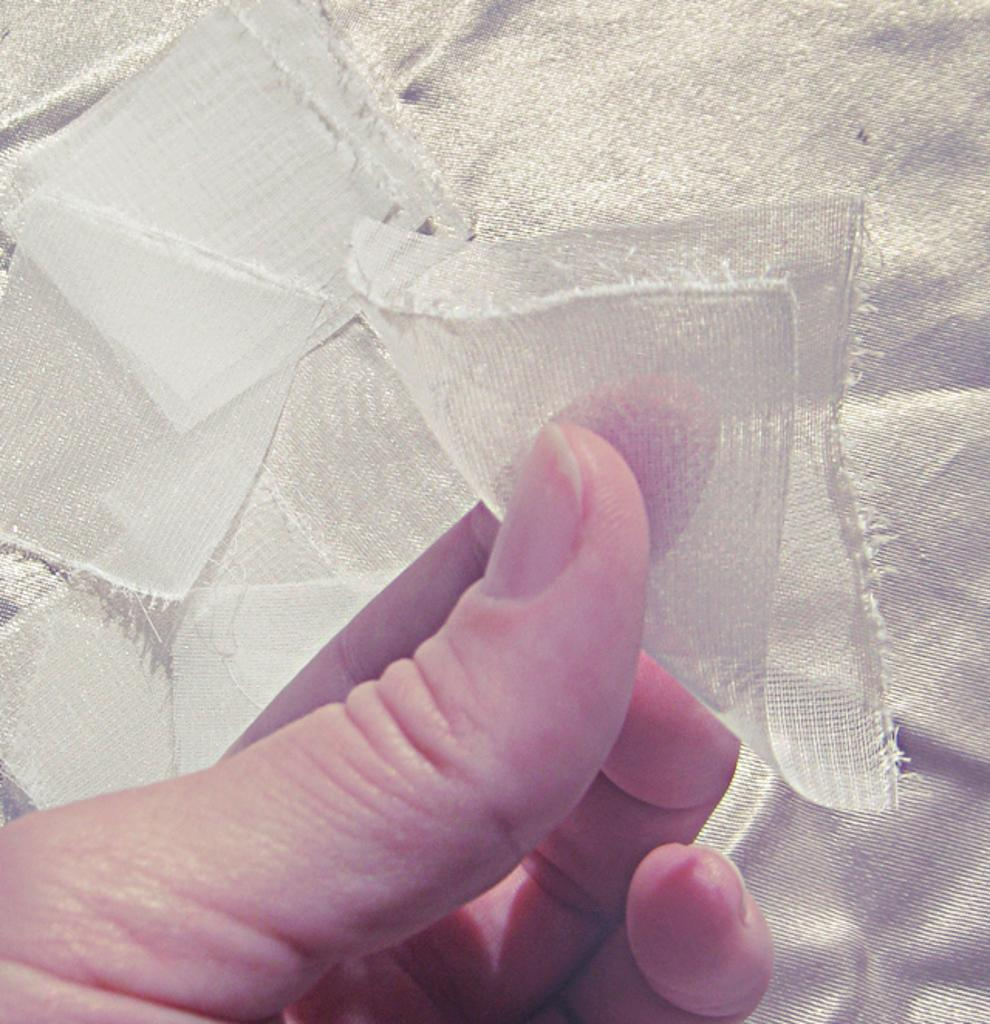Who or what is present in the image? There is a person in the image. What is the person holding in their hand? The person is holding pieces of cloth in their hand. Where is the kitty's nest located in the image? There is no kitty or nest present in the image. 